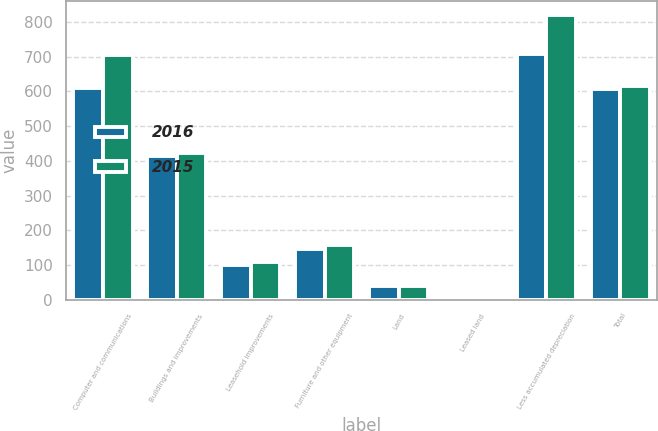<chart> <loc_0><loc_0><loc_500><loc_500><stacked_bar_chart><ecel><fcel>Computer and communications<fcel>Buildings and improvements<fcel>Leasehold improvements<fcel>Furniture and other equipment<fcel>Land<fcel>Leased land<fcel>Less accumulated depreciation<fcel>Total<nl><fcel>2016<fcel>610.8<fcel>415.1<fcel>98.7<fcel>145.9<fcel>40.3<fcel>2.7<fcel>706.4<fcel>607.1<nl><fcel>2015<fcel>704<fcel>422<fcel>108.2<fcel>158.3<fcel>40.3<fcel>2.7<fcel>820.4<fcel>615.1<nl></chart> 